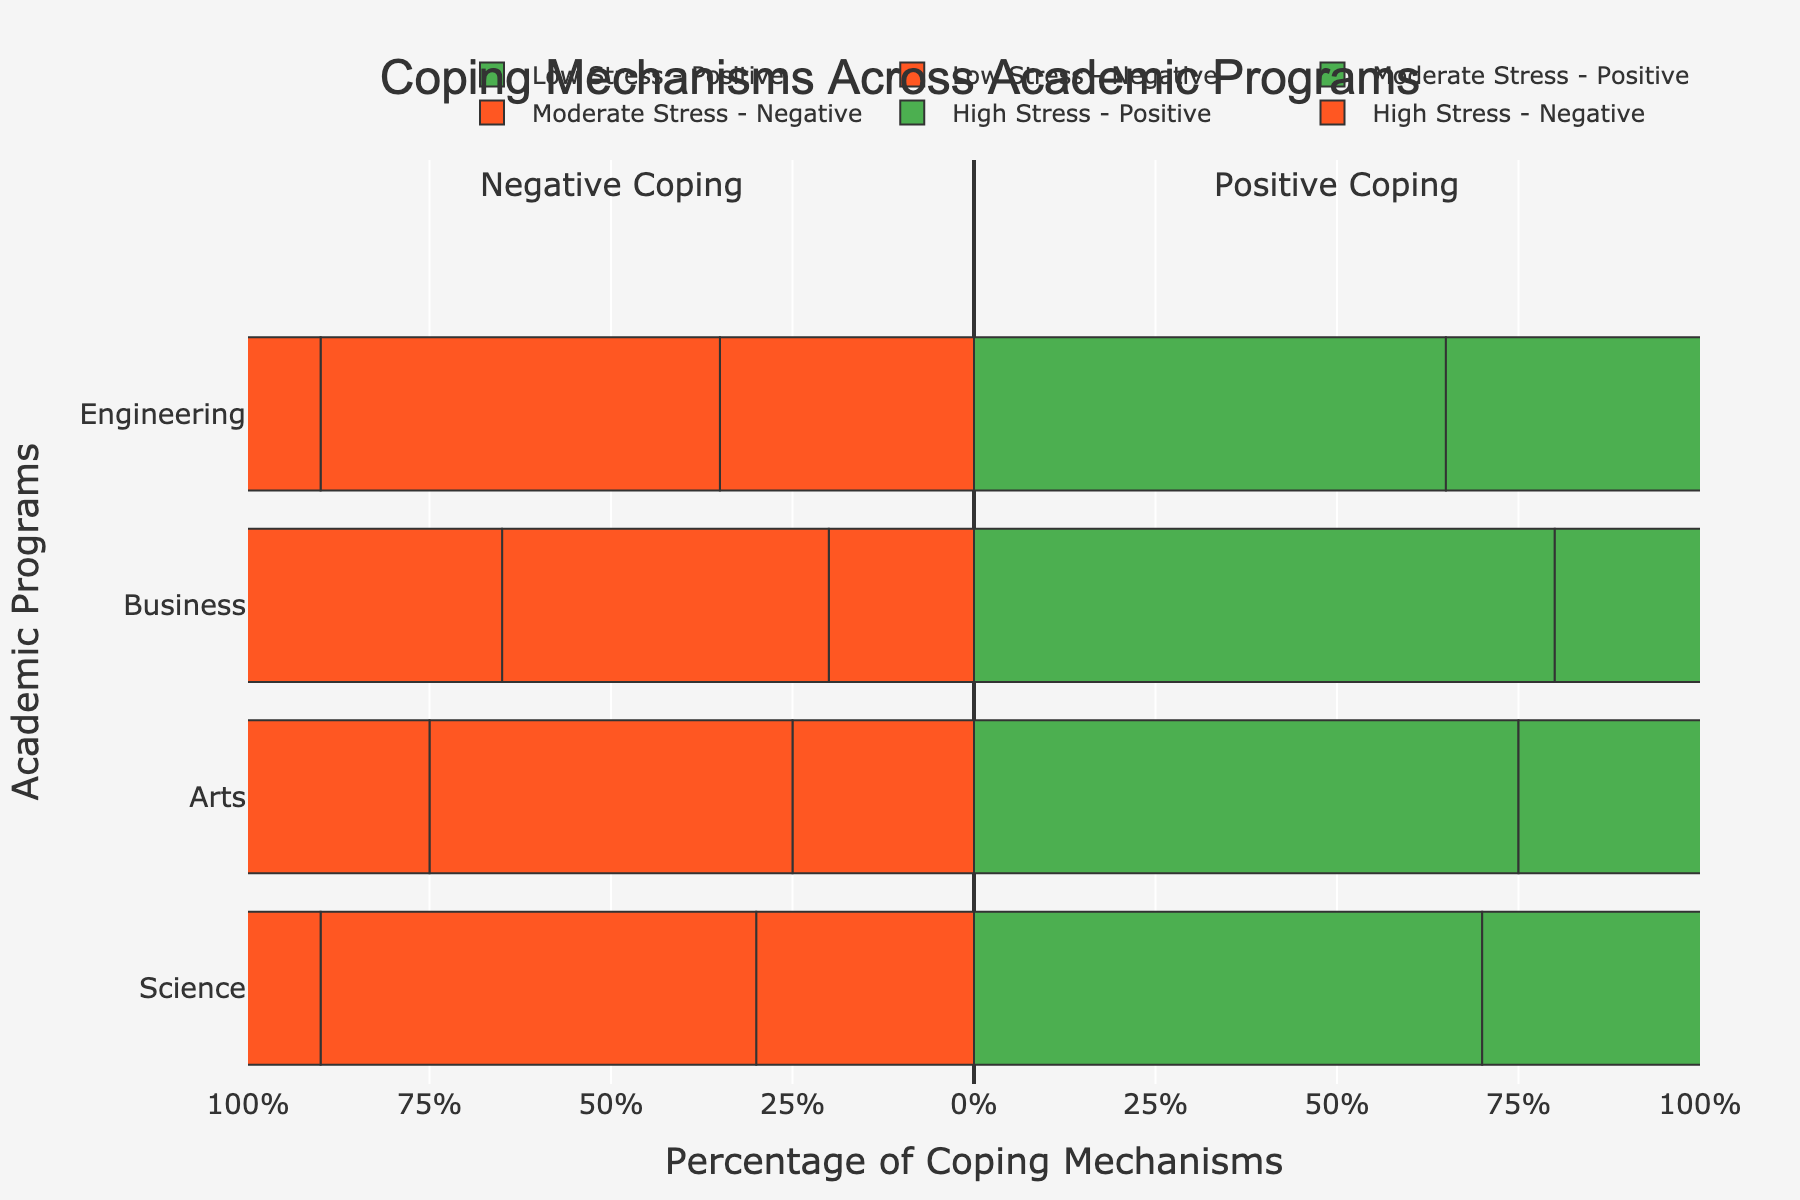Which academic program has the highest percentage of positive coping mechanisms among students with low stress levels? The percentage of positive coping mechanisms for each program at low stress levels can be read directly from the figure. The values are Science (70%), Arts (75%), Business (80%), Engineering (65%). Business has the highest percentage of positive coping mechanisms among students with low stress levels.
Answer: Business How does the percentage of negative coping mechanisms differ between high stress Science students and high stress Engineering students? The percentage of negative coping mechanisms for high stress levels in Science is 80% and in Engineering, it is 85%. The difference is calculated as 85% - 80% = 5%.
Answer: 5% Which program shows the smallest difference between positive and negative coping mechanisms at moderate stress levels? Check the positive and negative coping percentages for moderate stress levels across all programs: Science (40% positive, 60% negative), Arts (50% positive, 50% negative), Business (55% positive, 45% negative), Engineering (45% positive, 55% negative). The smallest difference is in Arts, where the difference is 0% (50% - 50%).
Answer: Arts In which academic program do students with low stress levels exhibit more negative coping than positive coping mechanisms? Based on the figure for low stress levels, we look for a program where the negative coping percentage is greater than the positive: Science (30% vs. 70%), Arts (25% vs. 75%), Business (20% vs. 80%), Engineering (35% vs. 65%). None of the programs fit this criterion.
Answer: None What is the average percentage of positive coping mechanisms across all programs at high stress levels? Calculate the positive coping percentages for high stress levels: Science (20%), Arts (30%), Business (25%), Engineering (15%). Sum these percentages and divide by the number of programs: (20 + 30 + 25 + 15) / 4 = 22.5%.
Answer: 22.5% Which academic program demonstrates the highest overall utilization of positive coping mechanisms across all stress levels? To answer this, sum the percentages of positive coping mechanisms for each stress level within a program, and compare the totals: 
Science (20% + 40% + 70%) = 130%, 
Arts (30% + 50% + 75%) = 155%, 
Business (25% + 55% + 80%) = 160%, 
Engineering (15% + 45% + 65%) = 125%. Business has the highest total percentage for positive coping mechanisms.
Answer: Business 